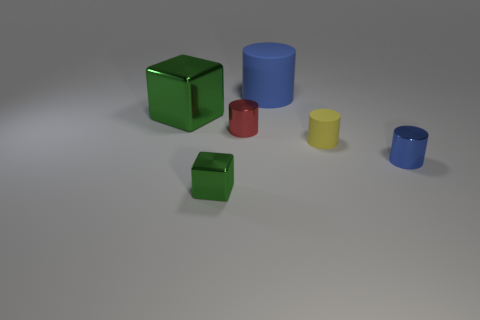Add 2 cylinders. How many objects exist? 8 Subtract all cylinders. How many objects are left? 2 Add 1 large metallic things. How many large metallic things exist? 2 Subtract 2 green blocks. How many objects are left? 4 Subtract all green blocks. Subtract all large green shiny objects. How many objects are left? 3 Add 6 tiny metal things. How many tiny metal things are left? 9 